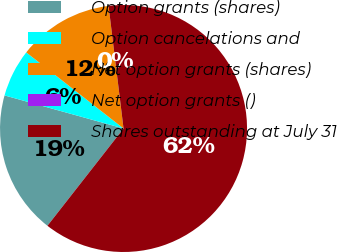Convert chart to OTSL. <chart><loc_0><loc_0><loc_500><loc_500><pie_chart><fcel>Option grants (shares)<fcel>Option cancelations and<fcel>Net option grants (shares)<fcel>Net option grants ()<fcel>Shares outstanding at July 31<nl><fcel>18.75%<fcel>6.25%<fcel>12.5%<fcel>0.0%<fcel>62.5%<nl></chart> 